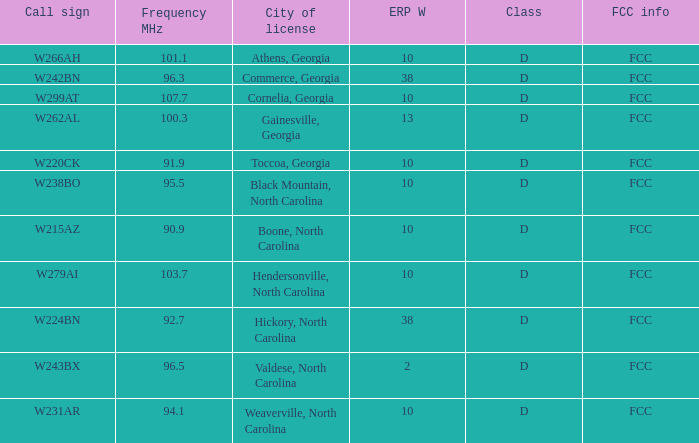What category does the city of black mountain, north carolina belong to? D. 